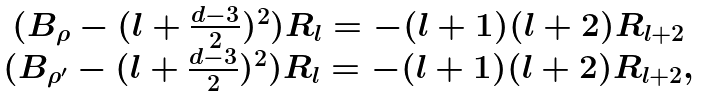Convert formula to latex. <formula><loc_0><loc_0><loc_500><loc_500>\begin{array} { c } ( B _ { \rho } - ( l + \frac { d - 3 } { 2 } ) ^ { 2 } ) R _ { l } = - ( l + 1 ) ( l + 2 ) R _ { l + 2 } \\ ( B _ { \rho ^ { \prime } } - ( l + \frac { d - 3 } { 2 } ) ^ { 2 } ) R _ { l } = - ( l + 1 ) ( l + 2 ) R _ { l + 2 } , \end{array}</formula> 